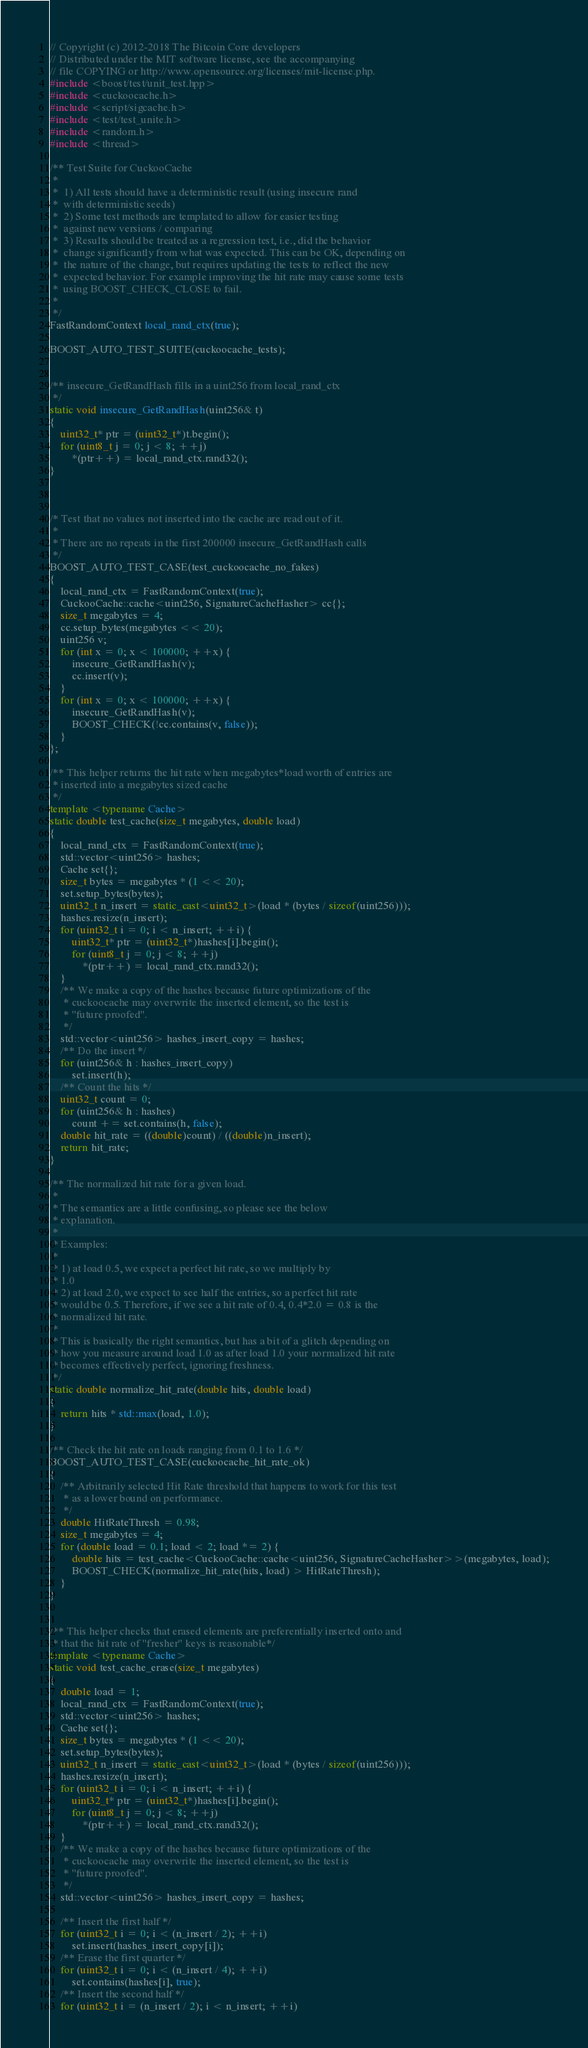<code> <loc_0><loc_0><loc_500><loc_500><_C++_>// Copyright (c) 2012-2018 The Bitcoin Core developers
// Distributed under the MIT software license, see the accompanying
// file COPYING or http://www.opensource.org/licenses/mit-license.php.
#include <boost/test/unit_test.hpp>
#include <cuckoocache.h>
#include <script/sigcache.h>
#include <test/test_unite.h>
#include <random.h>
#include <thread>

/** Test Suite for CuckooCache
 *
 *  1) All tests should have a deterministic result (using insecure rand
 *  with deterministic seeds)
 *  2) Some test methods are templated to allow for easier testing
 *  against new versions / comparing
 *  3) Results should be treated as a regression test, i.e., did the behavior
 *  change significantly from what was expected. This can be OK, depending on
 *  the nature of the change, but requires updating the tests to reflect the new
 *  expected behavior. For example improving the hit rate may cause some tests
 *  using BOOST_CHECK_CLOSE to fail.
 *
 */
FastRandomContext local_rand_ctx(true);

BOOST_AUTO_TEST_SUITE(cuckoocache_tests);


/** insecure_GetRandHash fills in a uint256 from local_rand_ctx
 */
static void insecure_GetRandHash(uint256& t)
{
    uint32_t* ptr = (uint32_t*)t.begin();
    for (uint8_t j = 0; j < 8; ++j)
        *(ptr++) = local_rand_ctx.rand32();
}



/* Test that no values not inserted into the cache are read out of it.
 *
 * There are no repeats in the first 200000 insecure_GetRandHash calls
 */
BOOST_AUTO_TEST_CASE(test_cuckoocache_no_fakes)
{
    local_rand_ctx = FastRandomContext(true);
    CuckooCache::cache<uint256, SignatureCacheHasher> cc{};
    size_t megabytes = 4;
    cc.setup_bytes(megabytes << 20);
    uint256 v;
    for (int x = 0; x < 100000; ++x) {
        insecure_GetRandHash(v);
        cc.insert(v);
    }
    for (int x = 0; x < 100000; ++x) {
        insecure_GetRandHash(v);
        BOOST_CHECK(!cc.contains(v, false));
    }
};

/** This helper returns the hit rate when megabytes*load worth of entries are
 * inserted into a megabytes sized cache
 */
template <typename Cache>
static double test_cache(size_t megabytes, double load)
{
    local_rand_ctx = FastRandomContext(true);
    std::vector<uint256> hashes;
    Cache set{};
    size_t bytes = megabytes * (1 << 20);
    set.setup_bytes(bytes);
    uint32_t n_insert = static_cast<uint32_t>(load * (bytes / sizeof(uint256)));
    hashes.resize(n_insert);
    for (uint32_t i = 0; i < n_insert; ++i) {
        uint32_t* ptr = (uint32_t*)hashes[i].begin();
        for (uint8_t j = 0; j < 8; ++j)
            *(ptr++) = local_rand_ctx.rand32();
    }
    /** We make a copy of the hashes because future optimizations of the
     * cuckoocache may overwrite the inserted element, so the test is
     * "future proofed".
     */
    std::vector<uint256> hashes_insert_copy = hashes;
    /** Do the insert */
    for (uint256& h : hashes_insert_copy)
        set.insert(h);
    /** Count the hits */
    uint32_t count = 0;
    for (uint256& h : hashes)
        count += set.contains(h, false);
    double hit_rate = ((double)count) / ((double)n_insert);
    return hit_rate;
}

/** The normalized hit rate for a given load.
 *
 * The semantics are a little confusing, so please see the below
 * explanation.
 *
 * Examples:
 *
 * 1) at load 0.5, we expect a perfect hit rate, so we multiply by
 * 1.0
 * 2) at load 2.0, we expect to see half the entries, so a perfect hit rate
 * would be 0.5. Therefore, if we see a hit rate of 0.4, 0.4*2.0 = 0.8 is the
 * normalized hit rate.
 *
 * This is basically the right semantics, but has a bit of a glitch depending on
 * how you measure around load 1.0 as after load 1.0 your normalized hit rate
 * becomes effectively perfect, ignoring freshness.
 */
static double normalize_hit_rate(double hits, double load)
{
    return hits * std::max(load, 1.0);
}

/** Check the hit rate on loads ranging from 0.1 to 1.6 */
BOOST_AUTO_TEST_CASE(cuckoocache_hit_rate_ok)
{
    /** Arbitrarily selected Hit Rate threshold that happens to work for this test
     * as a lower bound on performance.
     */
    double HitRateThresh = 0.98;
    size_t megabytes = 4;
    for (double load = 0.1; load < 2; load *= 2) {
        double hits = test_cache<CuckooCache::cache<uint256, SignatureCacheHasher>>(megabytes, load);
        BOOST_CHECK(normalize_hit_rate(hits, load) > HitRateThresh);
    }
}


/** This helper checks that erased elements are preferentially inserted onto and
 * that the hit rate of "fresher" keys is reasonable*/
template <typename Cache>
static void test_cache_erase(size_t megabytes)
{
    double load = 1;
    local_rand_ctx = FastRandomContext(true);
    std::vector<uint256> hashes;
    Cache set{};
    size_t bytes = megabytes * (1 << 20);
    set.setup_bytes(bytes);
    uint32_t n_insert = static_cast<uint32_t>(load * (bytes / sizeof(uint256)));
    hashes.resize(n_insert);
    for (uint32_t i = 0; i < n_insert; ++i) {
        uint32_t* ptr = (uint32_t*)hashes[i].begin();
        for (uint8_t j = 0; j < 8; ++j)
            *(ptr++) = local_rand_ctx.rand32();
    }
    /** We make a copy of the hashes because future optimizations of the
     * cuckoocache may overwrite the inserted element, so the test is
     * "future proofed".
     */
    std::vector<uint256> hashes_insert_copy = hashes;

    /** Insert the first half */
    for (uint32_t i = 0; i < (n_insert / 2); ++i)
        set.insert(hashes_insert_copy[i]);
    /** Erase the first quarter */
    for (uint32_t i = 0; i < (n_insert / 4); ++i)
        set.contains(hashes[i], true);
    /** Insert the second half */
    for (uint32_t i = (n_insert / 2); i < n_insert; ++i)</code> 